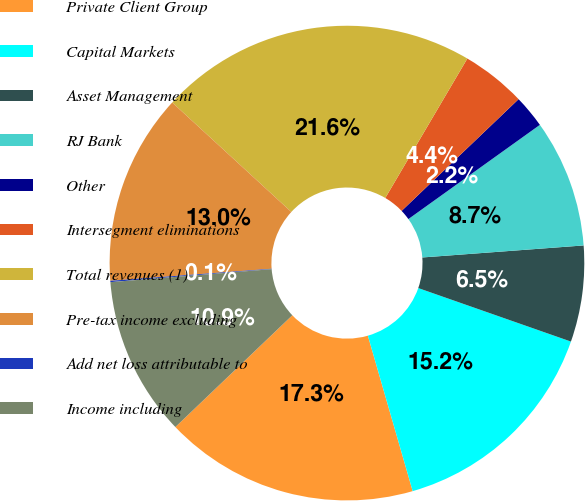<chart> <loc_0><loc_0><loc_500><loc_500><pie_chart><fcel>Private Client Group<fcel>Capital Markets<fcel>Asset Management<fcel>RJ Bank<fcel>Other<fcel>Intersegment eliminations<fcel>Total revenues (1)<fcel>Pre-tax income excluding<fcel>Add net loss attributable to<fcel>Income including<nl><fcel>17.33%<fcel>15.17%<fcel>6.55%<fcel>8.71%<fcel>2.24%<fcel>4.4%<fcel>21.64%<fcel>13.02%<fcel>0.09%<fcel>10.86%<nl></chart> 